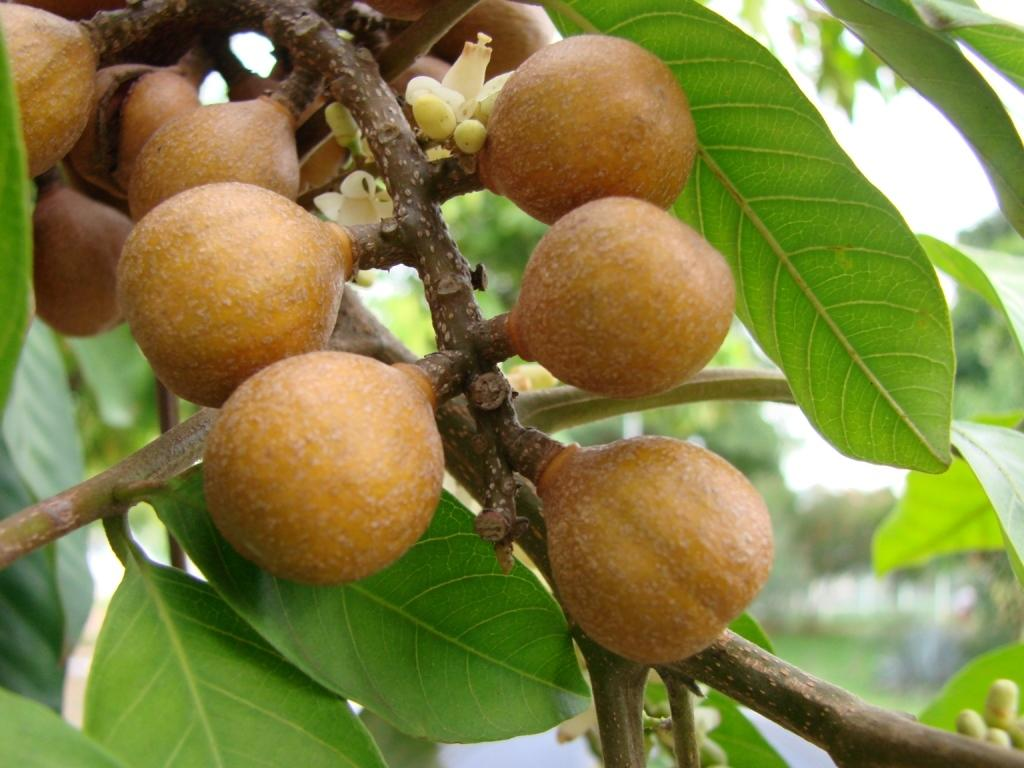What is present in the image? There is a tree in the image. What is special about the tree? The tree has fruits on it. What can be said about the color of the fruits? The fruits are brown in color. What type of writer is sitting under the tree in the image? There is no writer present in the image; it only features a tree with brown fruits. 